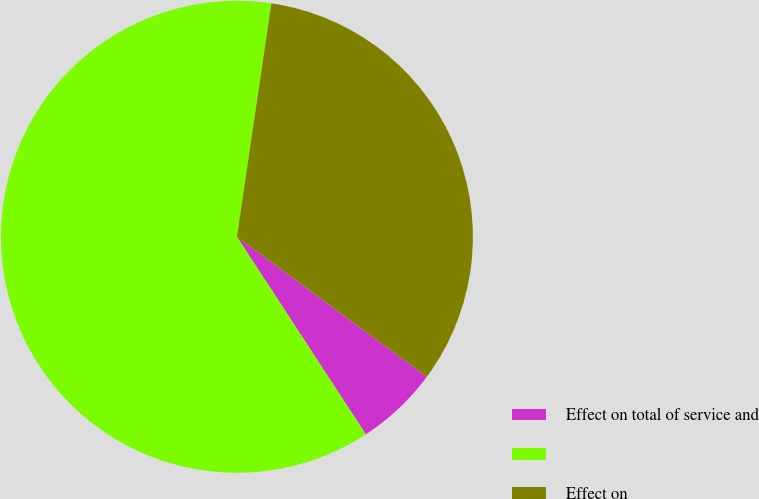Convert chart. <chart><loc_0><loc_0><loc_500><loc_500><pie_chart><fcel>Effect on total of service and<fcel>Unnamed: 1<fcel>Effect on<nl><fcel>5.69%<fcel>61.54%<fcel>32.78%<nl></chart> 